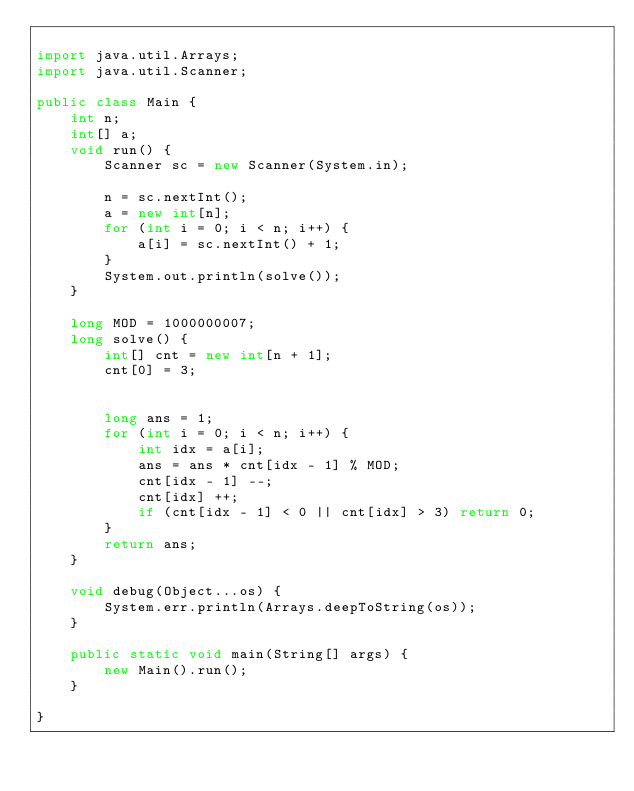<code> <loc_0><loc_0><loc_500><loc_500><_Java_>
import java.util.Arrays;
import java.util.Scanner;

public class Main {
    int n;
    int[] a;
    void run() {
        Scanner sc = new Scanner(System.in);

        n = sc.nextInt();
        a = new int[n];
        for (int i = 0; i < n; i++) {
            a[i] = sc.nextInt() + 1;
        }
        System.out.println(solve());
    }

    long MOD = 1000000007;
    long solve() {
        int[] cnt = new int[n + 1];
        cnt[0] = 3;


        long ans = 1;
        for (int i = 0; i < n; i++) {
            int idx = a[i];
            ans = ans * cnt[idx - 1] % MOD;
            cnt[idx - 1] --;
            cnt[idx] ++;
            if (cnt[idx - 1] < 0 || cnt[idx] > 3) return 0;
        }
        return ans;
    }

    void debug(Object...os) {
        System.err.println(Arrays.deepToString(os));
    }

    public static void main(String[] args) {
        new Main().run();
    }

}
</code> 